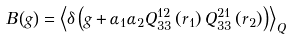Convert formula to latex. <formula><loc_0><loc_0><loc_500><loc_500>B \left ( g \right ) = \left \langle \delta \left ( g + \alpha _ { 1 } \alpha _ { 2 } Q _ { 3 3 } ^ { 1 2 } \left ( r _ { 1 } \right ) Q _ { 3 3 } ^ { 2 1 } \left ( r _ { 2 } \right ) \right ) \right \rangle _ { Q }</formula> 